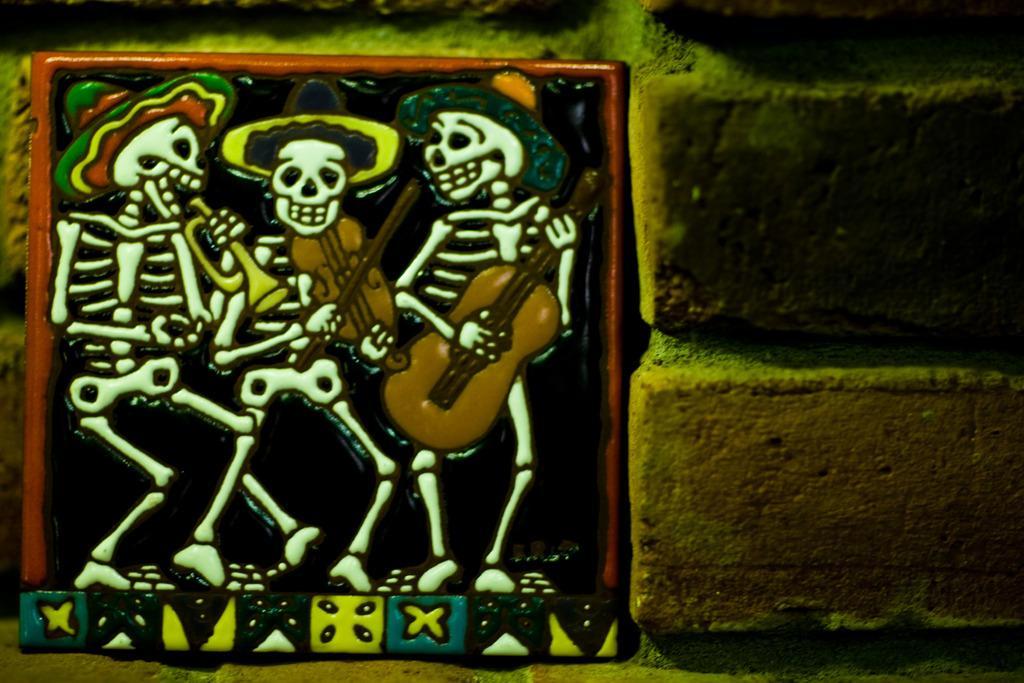Could you give a brief overview of what you see in this image? In this image there is a tile attached on the wall, on the tile there is the image of three skeletons playing guitar. 